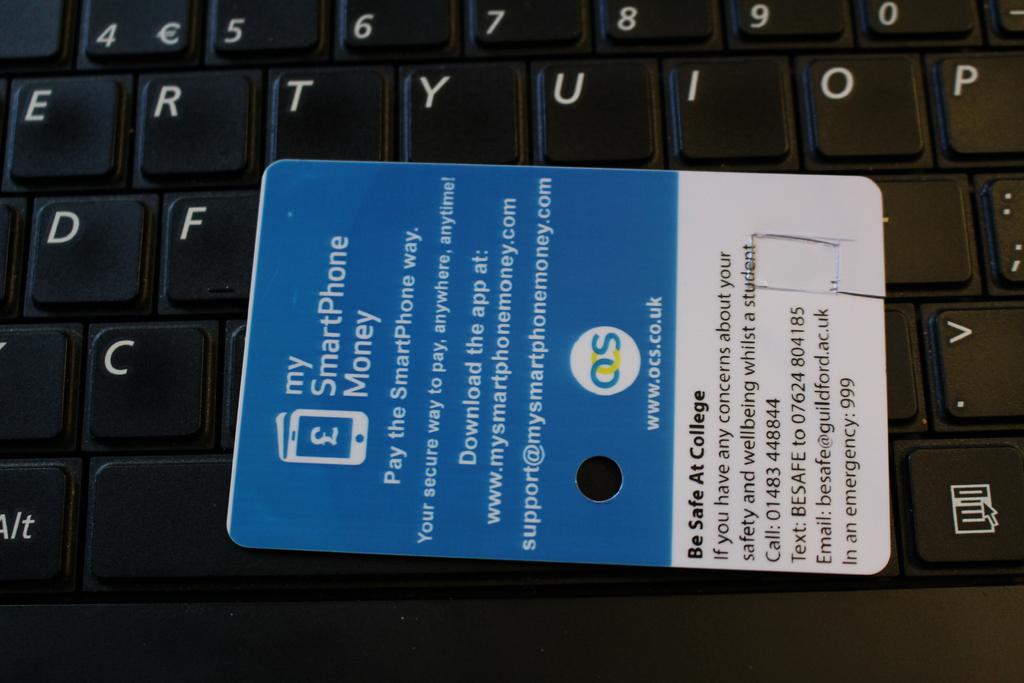What's the title of the card?
Make the answer very short. My smartphone money. What does the last sentense say?
Provide a short and direct response. In an emergency: 999. 